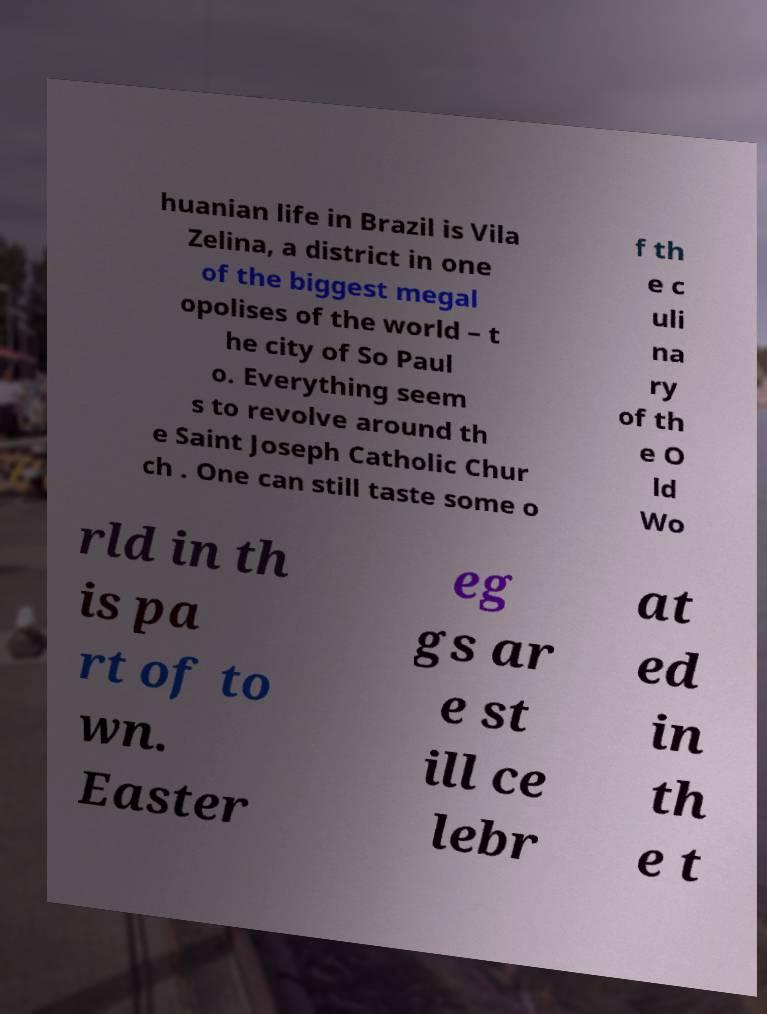Can you read and provide the text displayed in the image?This photo seems to have some interesting text. Can you extract and type it out for me? huanian life in Brazil is Vila Zelina, a district in one of the biggest megal opolises of the world – t he city of So Paul o. Everything seem s to revolve around th e Saint Joseph Catholic Chur ch . One can still taste some o f th e c uli na ry of th e O ld Wo rld in th is pa rt of to wn. Easter eg gs ar e st ill ce lebr at ed in th e t 